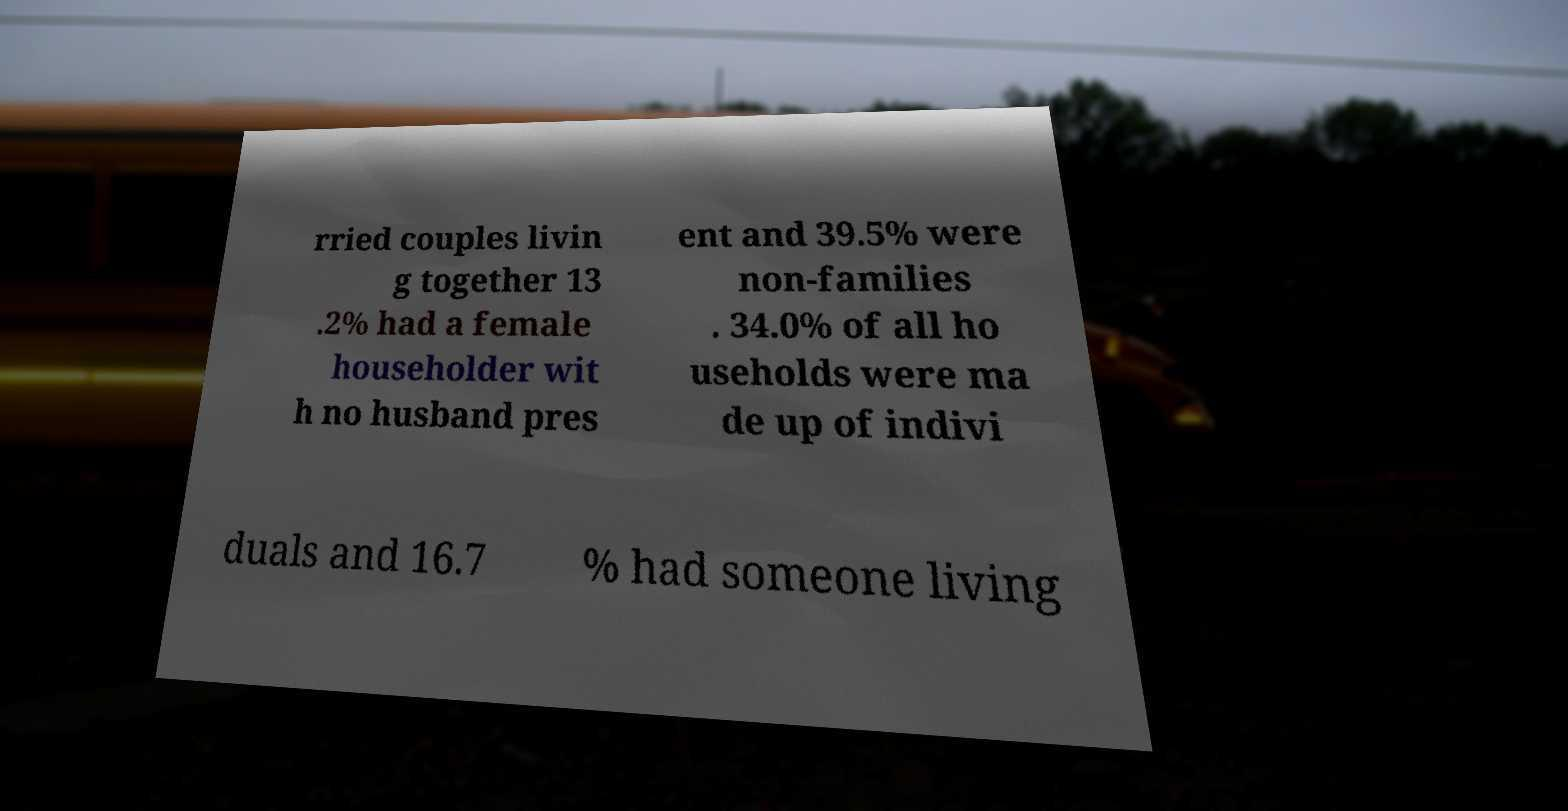Please identify and transcribe the text found in this image. rried couples livin g together 13 .2% had a female householder wit h no husband pres ent and 39.5% were non-families . 34.0% of all ho useholds were ma de up of indivi duals and 16.7 % had someone living 